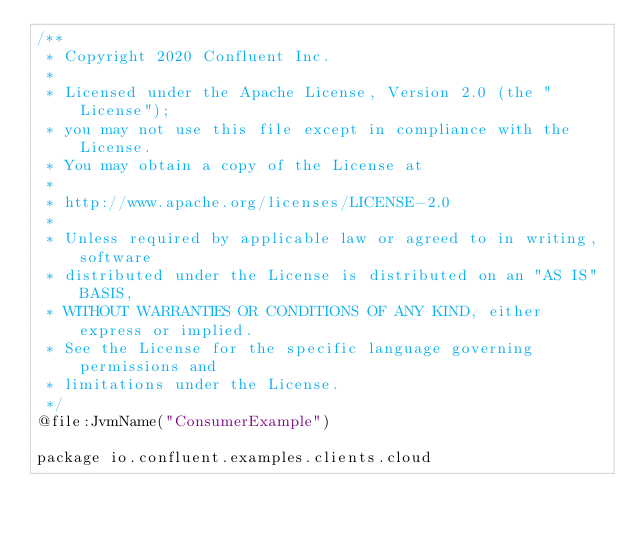Convert code to text. <code><loc_0><loc_0><loc_500><loc_500><_Kotlin_>/**
 * Copyright 2020 Confluent Inc.
 *
 * Licensed under the Apache License, Version 2.0 (the "License");
 * you may not use this file except in compliance with the License.
 * You may obtain a copy of the License at
 *
 * http://www.apache.org/licenses/LICENSE-2.0
 *
 * Unless required by applicable law or agreed to in writing, software
 * distributed under the License is distributed on an "AS IS" BASIS,
 * WITHOUT WARRANTIES OR CONDITIONS OF ANY KIND, either express or implied.
 * See the License for the specific language governing permissions and
 * limitations under the License.
 */
@file:JvmName("ConsumerExample")

package io.confluent.examples.clients.cloud
</code> 